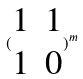Convert formula to latex. <formula><loc_0><loc_0><loc_500><loc_500>( \begin{matrix} 1 & 1 \\ 1 & 0 \end{matrix} ) ^ { m }</formula> 